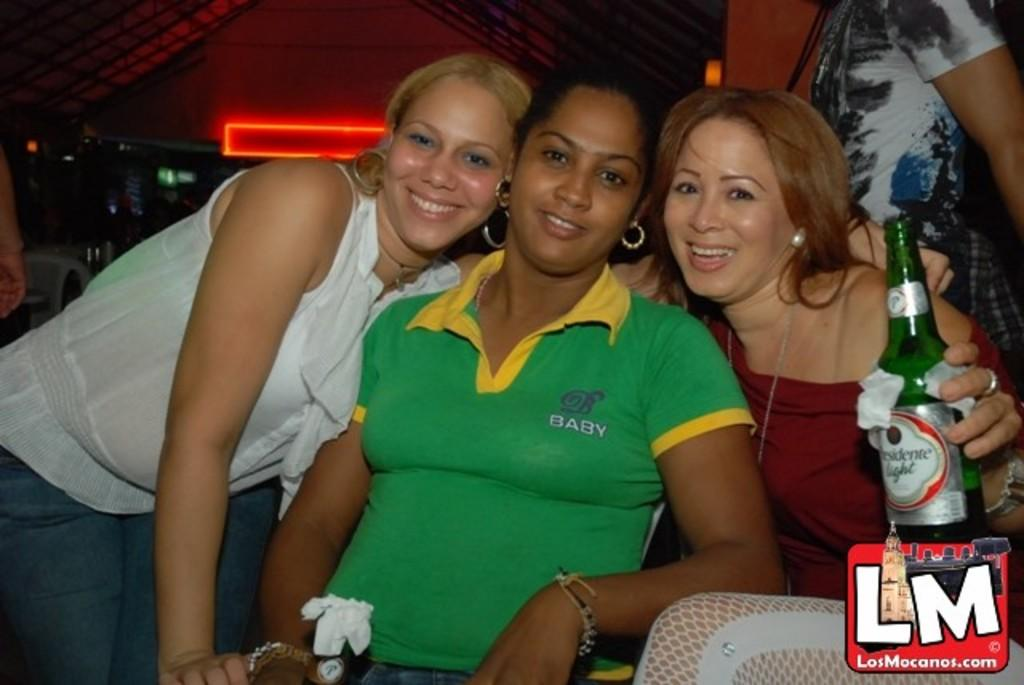How many people are in the image? There are three women in the image. What is one of the women holding? One of the women is holding a beer bottle. What can be seen in the background or surroundings of the image? There is a red neon light visible in the image. How many rabbits are visible in the image? There are no rabbits present in the image. What type of apparatus is being used by the women in the image? The provided facts do not mention any specific apparatus being used by the women in the image. 